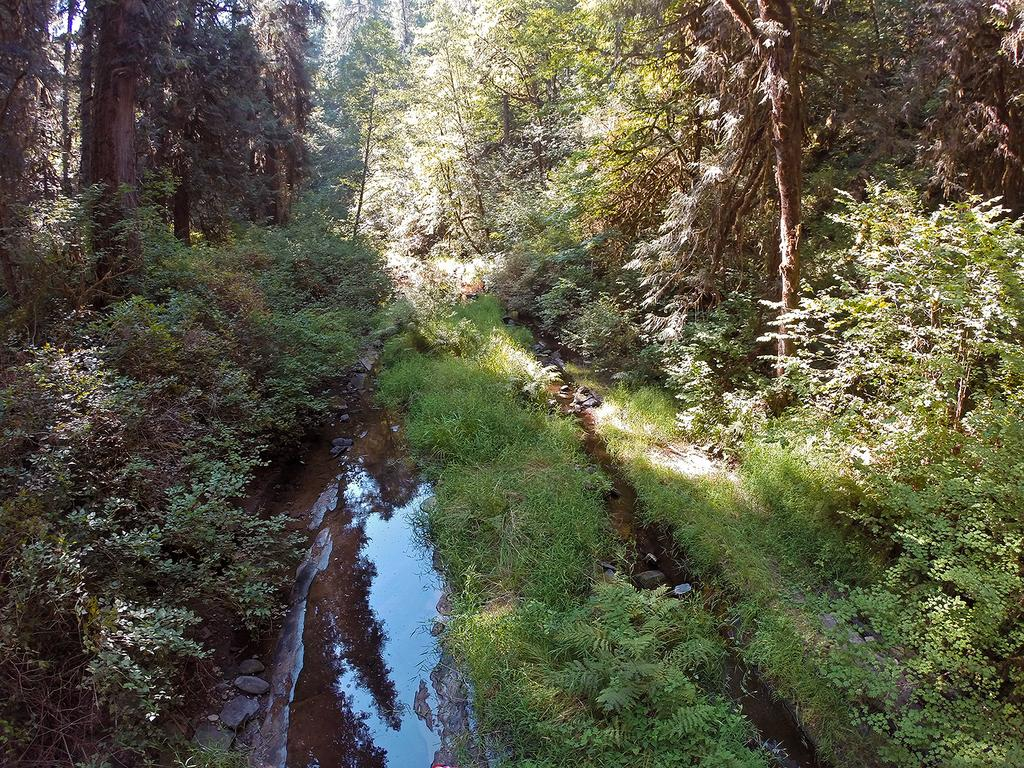What type of vegetation is present at the bottom of the image? There is grass and water visible at the bottom of the image. What other types of vegetation can be seen in the image? There are small plants in the image. What is the predominant feature in the image? There are many trees in the image. Can you touch the geese in the image? There are no geese present in the image, so it is not possible to touch them. 